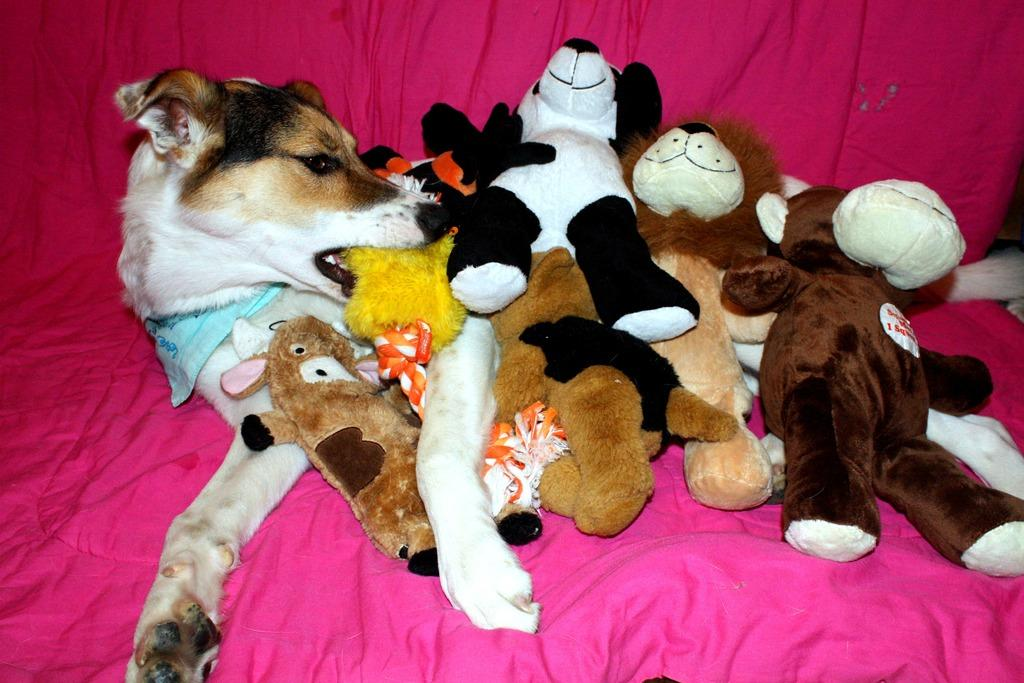What animal can be seen in the image? There is a dog in the image. What is the dog laying on? The dog is laying on a pink cloth. Are there any objects on the dog? Yes, there are toys on the dog. What type of plantation can be seen in the background of the image? There is no plantation visible in the image; it features a dog laying on a pink cloth with toys on it. How many goldfish are swimming in the bowl next to the dog? There is no bowl of goldfish present in the image. 